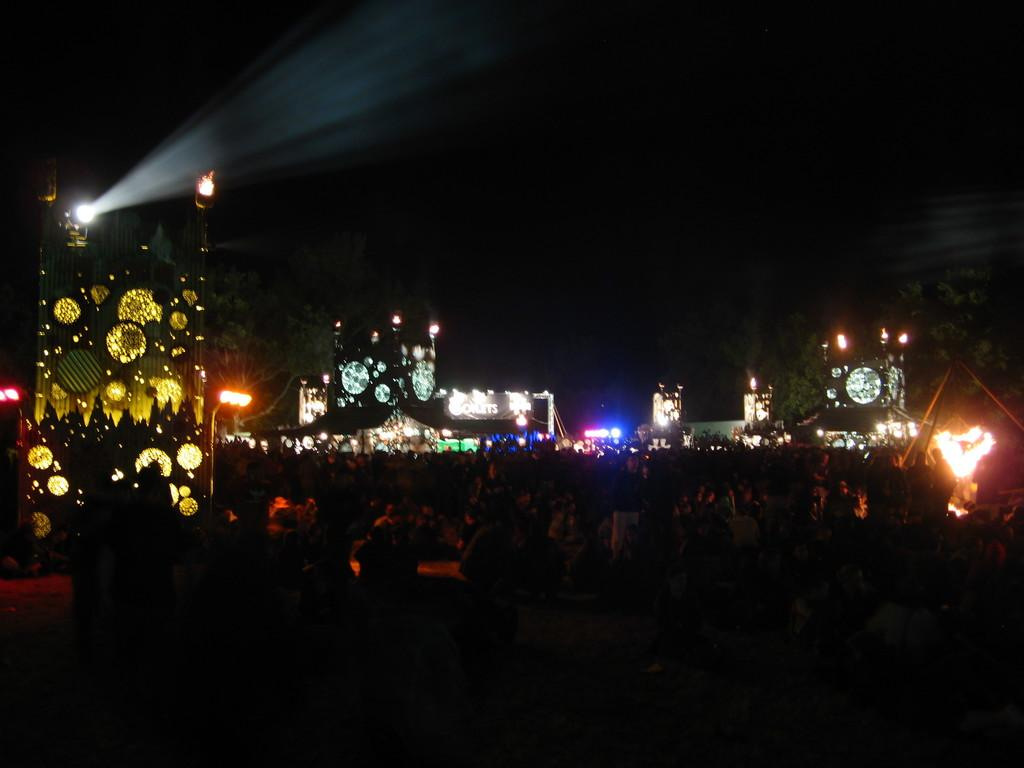Who or what is present in the image? There are people in the image. What can be seen illuminating the scene? There are lights visible in the image. What is the color of the background in the image? The background of the image is black in color. Where is the rabbit hiding in the image? There is no rabbit present in the image. What type of house is visible in the background of the image? There is no house visible in the image; the background is black. 